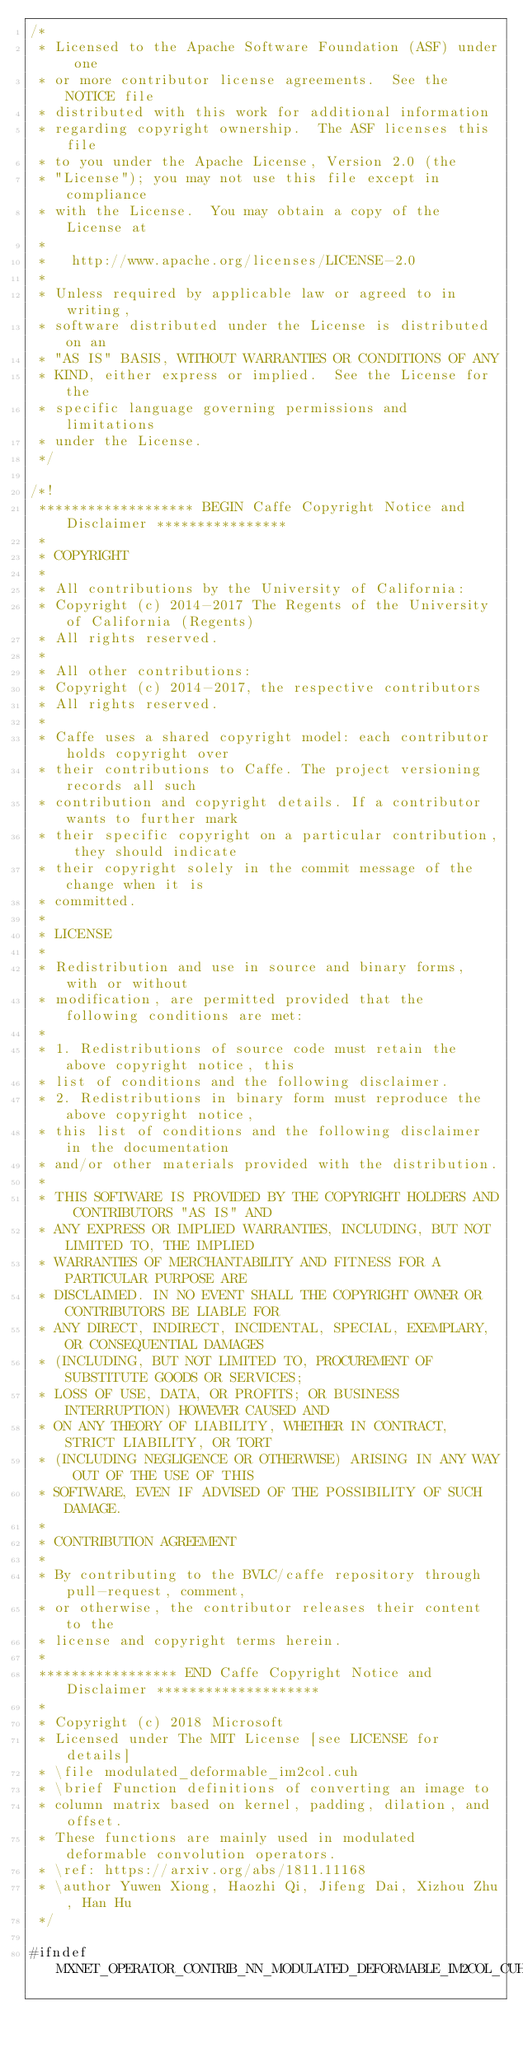<code> <loc_0><loc_0><loc_500><loc_500><_Cuda_>/*
 * Licensed to the Apache Software Foundation (ASF) under one
 * or more contributor license agreements.  See the NOTICE file
 * distributed with this work for additional information
 * regarding copyright ownership.  The ASF licenses this file
 * to you under the Apache License, Version 2.0 (the
 * "License"); you may not use this file except in compliance
 * with the License.  You may obtain a copy of the License at
 *
 *   http://www.apache.org/licenses/LICENSE-2.0
 *
 * Unless required by applicable law or agreed to in writing,
 * software distributed under the License is distributed on an
 * "AS IS" BASIS, WITHOUT WARRANTIES OR CONDITIONS OF ANY
 * KIND, either express or implied.  See the License for the
 * specific language governing permissions and limitations
 * under the License.
 */

/*!
 ******************* BEGIN Caffe Copyright Notice and Disclaimer ****************
 *
 * COPYRIGHT
 *
 * All contributions by the University of California:
 * Copyright (c) 2014-2017 The Regents of the University of California (Regents)
 * All rights reserved.
 *
 * All other contributions:
 * Copyright (c) 2014-2017, the respective contributors
 * All rights reserved.
 *
 * Caffe uses a shared copyright model: each contributor holds copyright over
 * their contributions to Caffe. The project versioning records all such
 * contribution and copyright details. If a contributor wants to further mark
 * their specific copyright on a particular contribution, they should indicate
 * their copyright solely in the commit message of the change when it is
 * committed.
 *
 * LICENSE
 *
 * Redistribution and use in source and binary forms, with or without
 * modification, are permitted provided that the following conditions are met:
 *
 * 1. Redistributions of source code must retain the above copyright notice, this
 * list of conditions and the following disclaimer.
 * 2. Redistributions in binary form must reproduce the above copyright notice,
 * this list of conditions and the following disclaimer in the documentation
 * and/or other materials provided with the distribution.
 *
 * THIS SOFTWARE IS PROVIDED BY THE COPYRIGHT HOLDERS AND CONTRIBUTORS "AS IS" AND
 * ANY EXPRESS OR IMPLIED WARRANTIES, INCLUDING, BUT NOT LIMITED TO, THE IMPLIED
 * WARRANTIES OF MERCHANTABILITY AND FITNESS FOR A PARTICULAR PURPOSE ARE
 * DISCLAIMED. IN NO EVENT SHALL THE COPYRIGHT OWNER OR CONTRIBUTORS BE LIABLE FOR
 * ANY DIRECT, INDIRECT, INCIDENTAL, SPECIAL, EXEMPLARY, OR CONSEQUENTIAL DAMAGES
 * (INCLUDING, BUT NOT LIMITED TO, PROCUREMENT OF SUBSTITUTE GOODS OR SERVICES;
 * LOSS OF USE, DATA, OR PROFITS; OR BUSINESS INTERRUPTION) HOWEVER CAUSED AND
 * ON ANY THEORY OF LIABILITY, WHETHER IN CONTRACT, STRICT LIABILITY, OR TORT
 * (INCLUDING NEGLIGENCE OR OTHERWISE) ARISING IN ANY WAY OUT OF THE USE OF THIS
 * SOFTWARE, EVEN IF ADVISED OF THE POSSIBILITY OF SUCH DAMAGE.
 *
 * CONTRIBUTION AGREEMENT
 *
 * By contributing to the BVLC/caffe repository through pull-request, comment,
 * or otherwise, the contributor releases their content to the
 * license and copyright terms herein.
 *
 ***************** END Caffe Copyright Notice and Disclaimer ********************
 *
 * Copyright (c) 2018 Microsoft
 * Licensed under The MIT License [see LICENSE for details]
 * \file modulated_deformable_im2col.cuh
 * \brief Function definitions of converting an image to
 * column matrix based on kernel, padding, dilation, and offset.
 * These functions are mainly used in modulated deformable convolution operators.
 * \ref: https://arxiv.org/abs/1811.11168
 * \author Yuwen Xiong, Haozhi Qi, Jifeng Dai, Xizhou Zhu, Han Hu
 */

#ifndef MXNET_OPERATOR_CONTRIB_NN_MODULATED_DEFORMABLE_IM2COL_CUH_</code> 